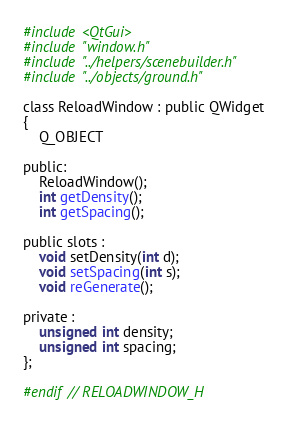Convert code to text. <code><loc_0><loc_0><loc_500><loc_500><_C_>
#include <QtGui>
#include "window.h"
#include "../helpers/scenebuilder.h"
#include "../objects/ground.h"

class ReloadWindow : public QWidget
{
    Q_OBJECT

public:
    ReloadWindow();
    int getDensity();
    int getSpacing();

public slots :
    void setDensity(int d);
    void setSpacing(int s);
    void reGenerate();

private :
    unsigned int density;
    unsigned int spacing;
};

#endif // RELOADWINDOW_H
</code> 